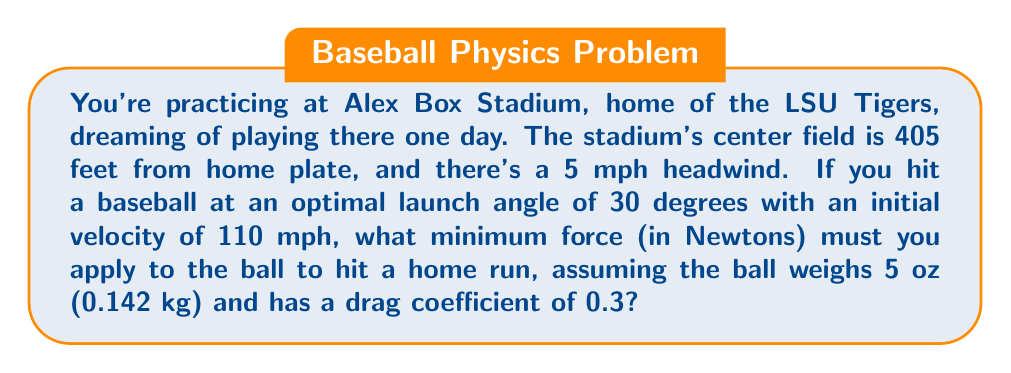Solve this math problem. Let's approach this step-by-step:

1) First, we need to calculate the time the ball is in the air. Using the projectile motion equation:

   $$d = v_0 \cos(\theta) t - \frac{1}{2}gt^2$$

   Where $d$ = 405 ft (123.44 m), $v_0$ = 110 mph (49.17 m/s), $\theta$ = 30°, and $g$ = 9.8 m/s².

2) Solving this quadratic equation gives us $t \approx 4.85$ seconds.

3) Now, we need to account for wind resistance. The drag force is given by:

   $$F_d = \frac{1}{2}\rho C_d A v^2$$

   Where $\rho$ is air density (1.225 kg/m³), $C_d$ is the drag coefficient (0.3), $A$ is the cross-sectional area of the ball (0.00426 m²), and $v$ is the velocity.

4) The headwind adds 5 mph (2.24 m/s) to the ball's velocity relative to the air. So the average velocity is:

   $$v_{avg} = 49.17 + 2.24 = 51.41 \text{ m/s}$$

5) Plugging this into the drag force equation:

   $$F_d = \frac{1}{2}(1.225)(0.3)(0.00426)(51.41^2) = 0.256 \text{ N}$$

6) The force needed to overcome this drag over the distance is:

   $$F_{drag} = F_d \cdot d = 0.256 \cdot 123.44 = 31.60 \text{ N}$$

7) The force needed to accelerate the ball to 110 mph is:

   $$F_{acc} = ma = 0.142 \cdot \frac{49.17}{t_{contact}} = 0.142 \cdot \frac{49.17}{0.001} = 6981.14 \text{ N}$$

   (Assuming a contact time of 0.001 seconds)

8) The total force required is the sum of these forces:

   $$F_{total} = F_{drag} + F_{acc} = 31.60 + 6981.14 = 7012.74 \text{ N}$$
Answer: 7012.74 N 